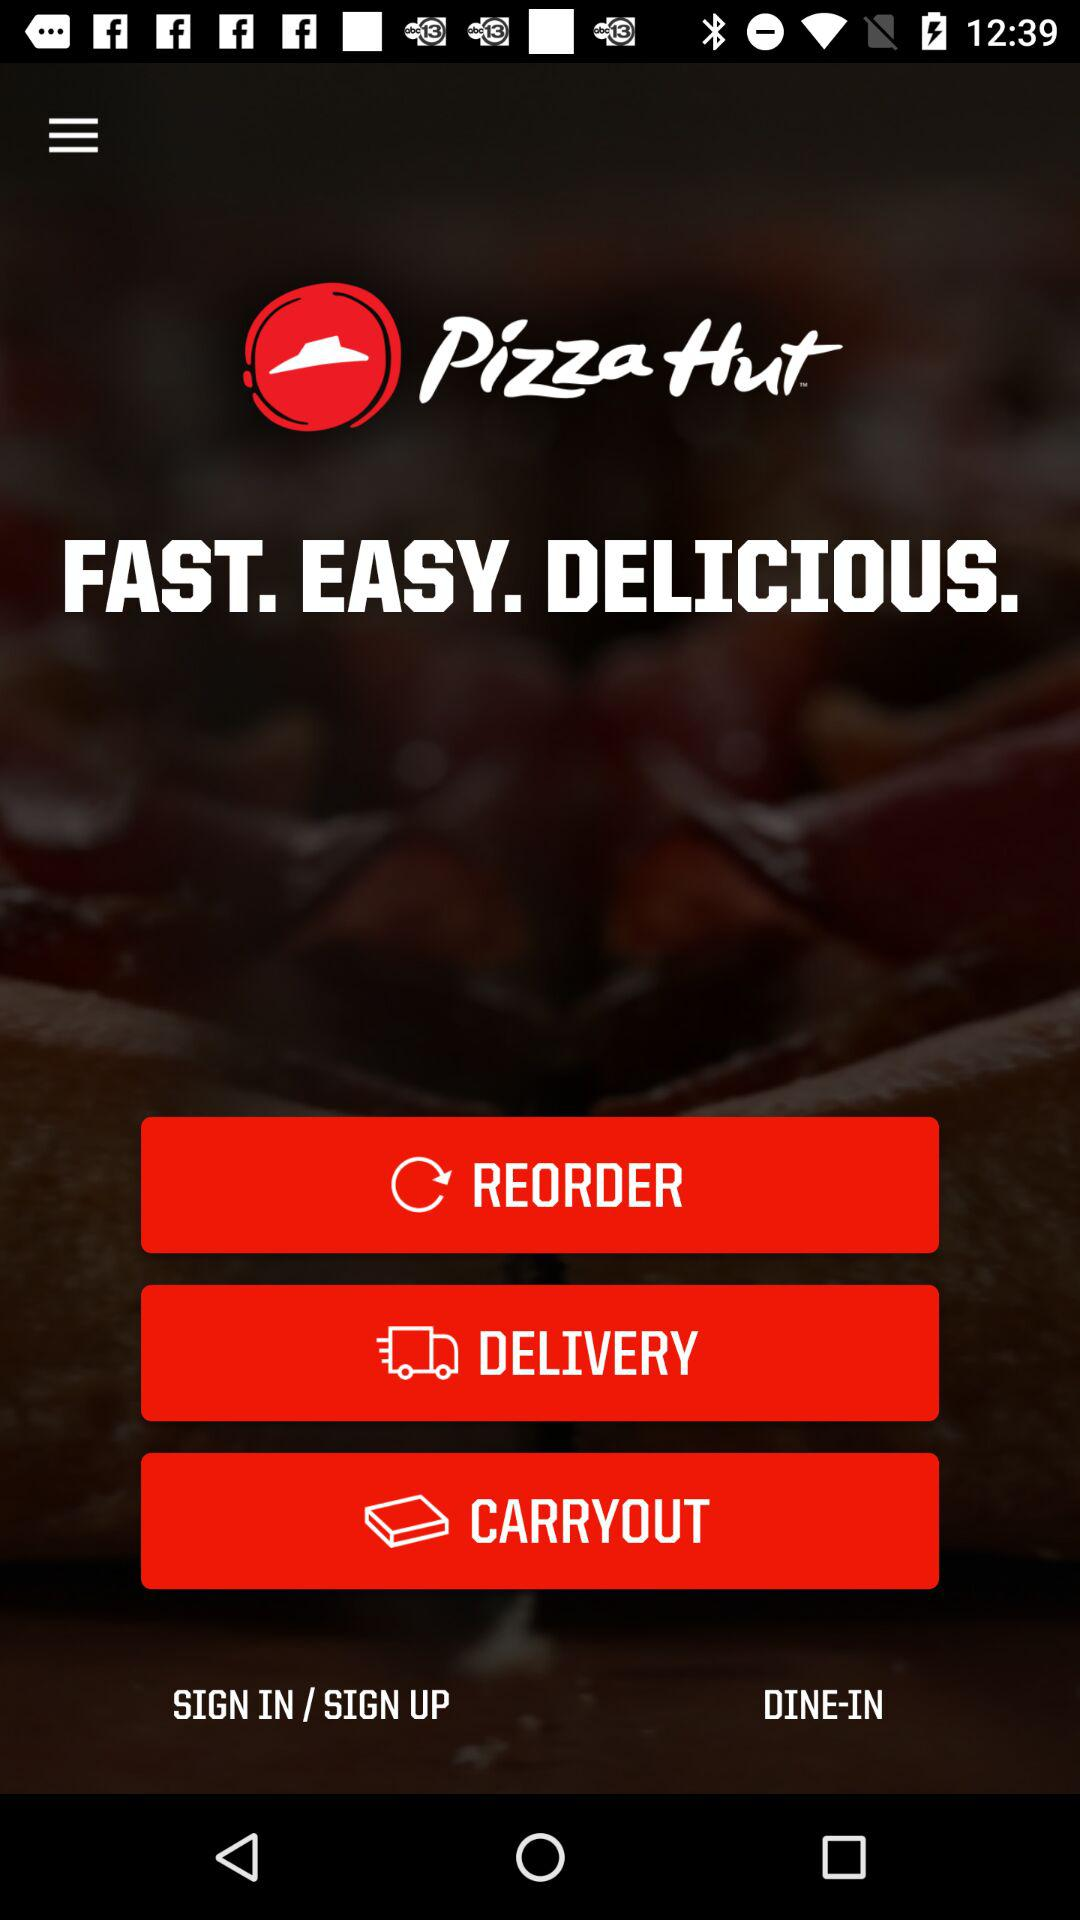What is the application name? The application name is "Pizza Hut™". 